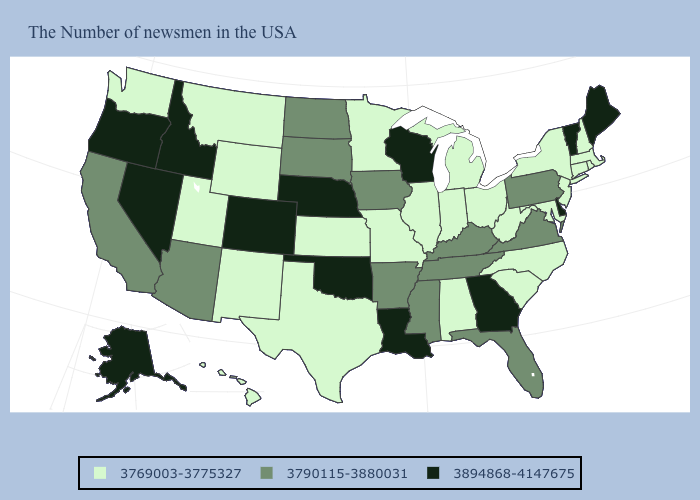Among the states that border Maryland , which have the lowest value?
Quick response, please. West Virginia. Which states have the lowest value in the MidWest?
Concise answer only. Ohio, Michigan, Indiana, Illinois, Missouri, Minnesota, Kansas. Does the map have missing data?
Quick response, please. No. Name the states that have a value in the range 3790115-3880031?
Concise answer only. Pennsylvania, Virginia, Florida, Kentucky, Tennessee, Mississippi, Arkansas, Iowa, South Dakota, North Dakota, Arizona, California. Does Nevada have the highest value in the West?
Keep it brief. Yes. Which states have the highest value in the USA?
Write a very short answer. Maine, Vermont, Delaware, Georgia, Wisconsin, Louisiana, Nebraska, Oklahoma, Colorado, Idaho, Nevada, Oregon, Alaska. What is the value of Vermont?
Quick response, please. 3894868-4147675. Among the states that border New Mexico , which have the lowest value?
Answer briefly. Texas, Utah. Name the states that have a value in the range 3894868-4147675?
Concise answer only. Maine, Vermont, Delaware, Georgia, Wisconsin, Louisiana, Nebraska, Oklahoma, Colorado, Idaho, Nevada, Oregon, Alaska. What is the highest value in the USA?
Concise answer only. 3894868-4147675. Does North Dakota have a lower value than Arizona?
Concise answer only. No. What is the highest value in states that border New Jersey?
Give a very brief answer. 3894868-4147675. What is the value of Delaware?
Keep it brief. 3894868-4147675. What is the lowest value in states that border Iowa?
Give a very brief answer. 3769003-3775327. Among the states that border Indiana , does Kentucky have the lowest value?
Short answer required. No. 